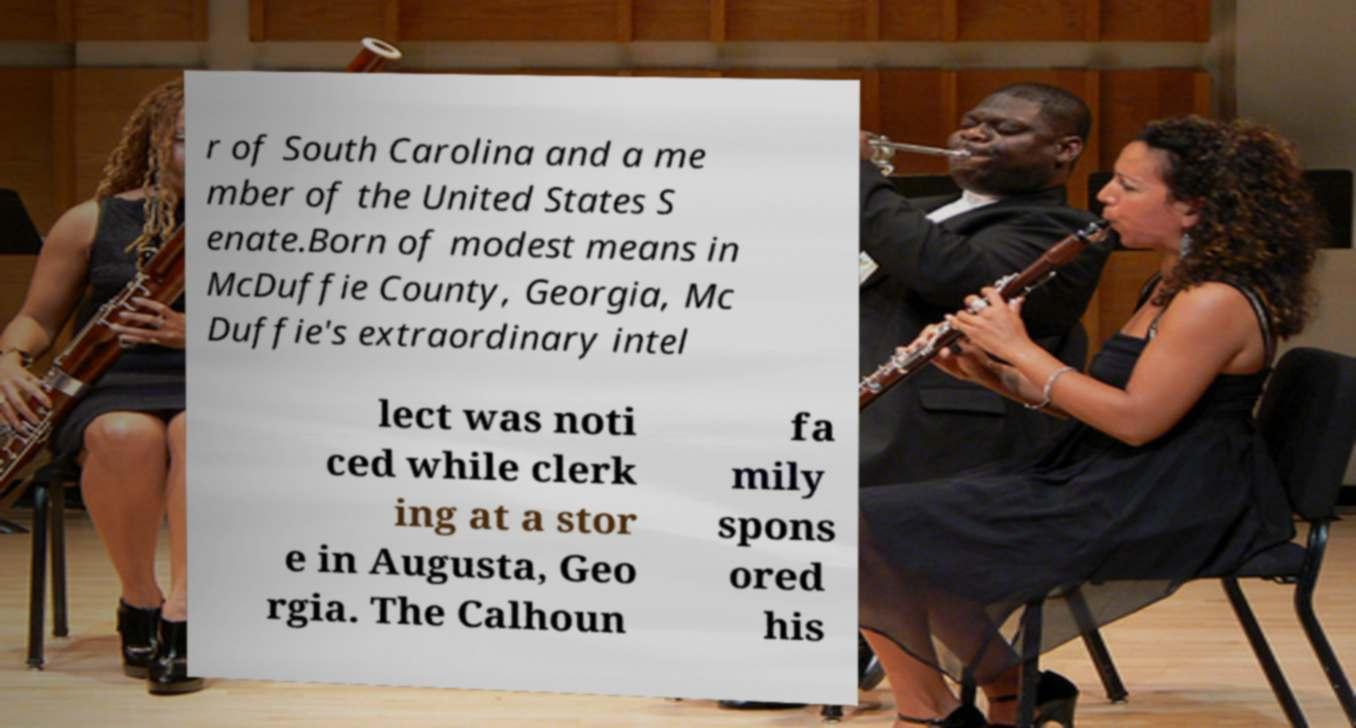For documentation purposes, I need the text within this image transcribed. Could you provide that? r of South Carolina and a me mber of the United States S enate.Born of modest means in McDuffie County, Georgia, Mc Duffie's extraordinary intel lect was noti ced while clerk ing at a stor e in Augusta, Geo rgia. The Calhoun fa mily spons ored his 